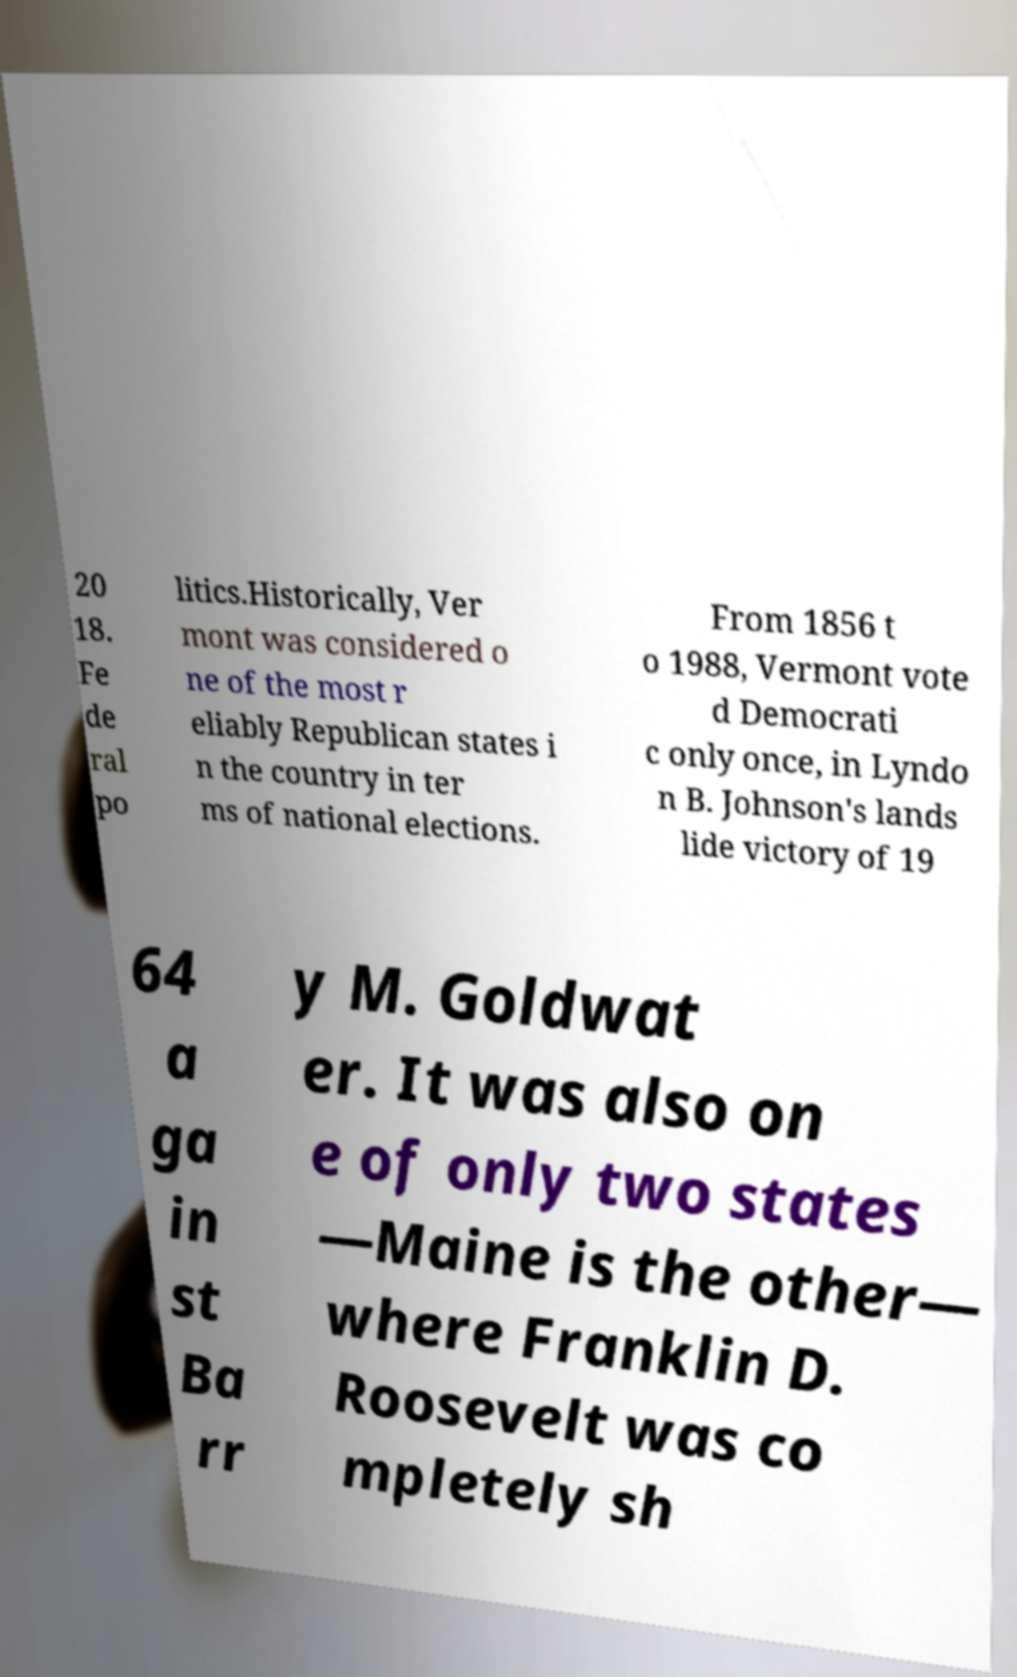There's text embedded in this image that I need extracted. Can you transcribe it verbatim? 20 18. Fe de ral po litics.Historically, Ver mont was considered o ne of the most r eliably Republican states i n the country in ter ms of national elections. From 1856 t o 1988, Vermont vote d Democrati c only once, in Lyndo n B. Johnson's lands lide victory of 19 64 a ga in st Ba rr y M. Goldwat er. It was also on e of only two states —Maine is the other— where Franklin D. Roosevelt was co mpletely sh 